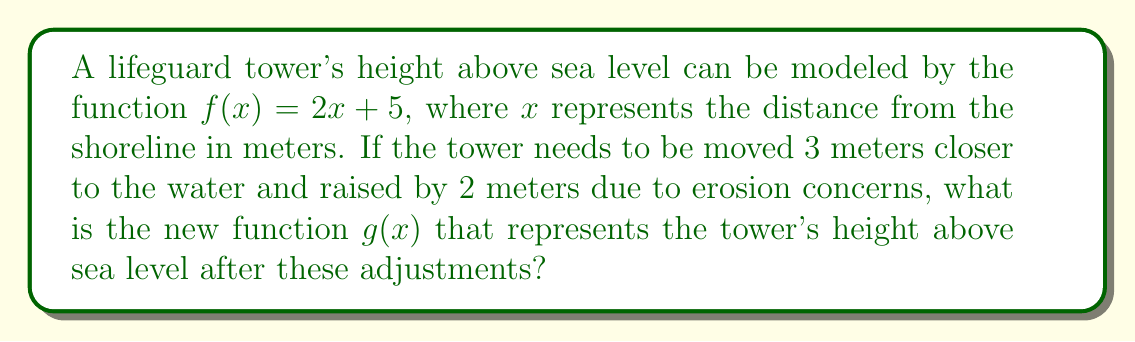Could you help me with this problem? To solve this problem, we need to apply vertical and horizontal shifts to the original function $f(x) = 2x + 5$.

1. Vertical shift:
   The tower is raised by 2 meters, which means we need to add 2 to the function.
   $f(x) + 2 = (2x + 5) + 2 = 2x + 7$

2. Horizontal shift:
   The tower is moved 3 meters closer to the water. Since $x$ represents the distance from the shoreline, we need to subtract 3 from $x$.
   Replace $x$ with $(x + 3)$ in the function from step 1:
   $2(x + 3) + 7$

3. Simplify the new function:
   $g(x) = 2(x + 3) + 7$
   $g(x) = 2x + 6 + 7$
   $g(x) = 2x + 13$

The new function $g(x) = 2x + 13$ represents the tower's height above sea level after the adjustments.
Answer: $g(x) = 2x + 13$ 